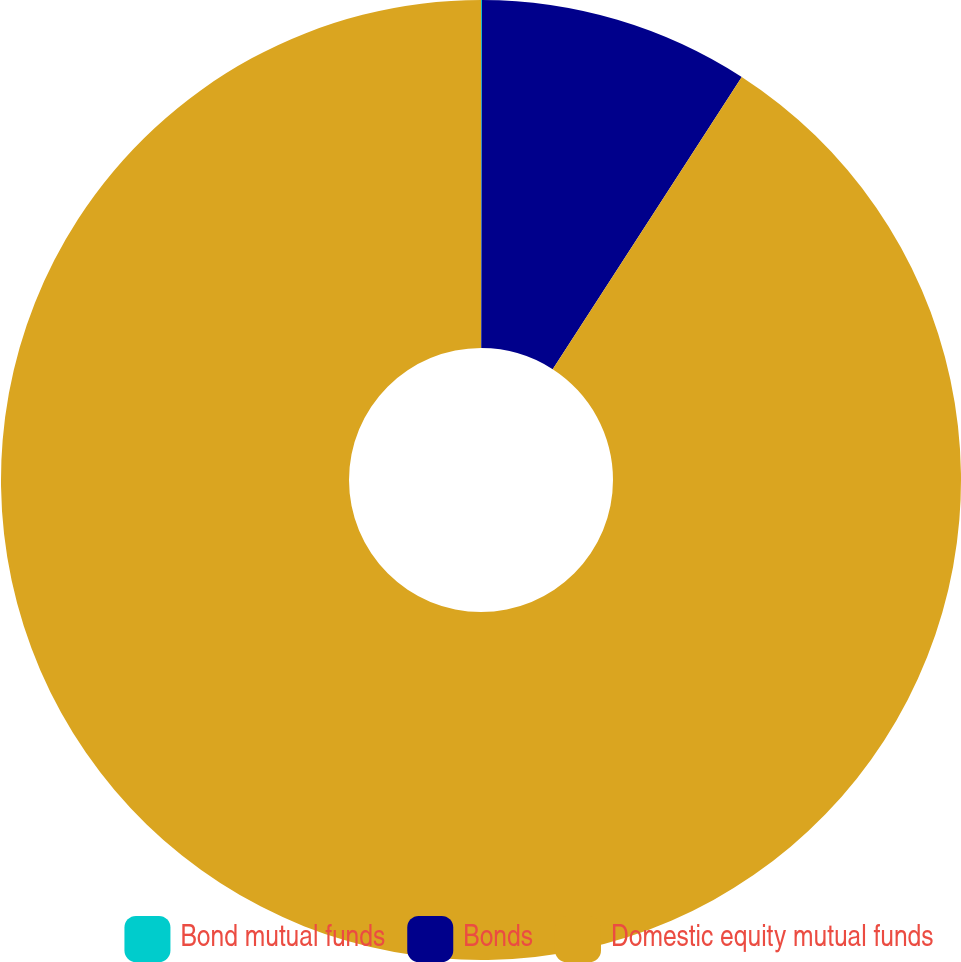<chart> <loc_0><loc_0><loc_500><loc_500><pie_chart><fcel>Bond mutual funds<fcel>Bonds<fcel>Domestic equity mutual funds<nl><fcel>0.03%<fcel>9.11%<fcel>90.86%<nl></chart> 